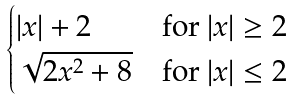Convert formula to latex. <formula><loc_0><loc_0><loc_500><loc_500>\begin{cases} | x | + 2 & \text {for } | x | \geq 2 \\ \sqrt { 2 x ^ { 2 } + 8 } & \text {for } | x | \leq 2 \end{cases}</formula> 